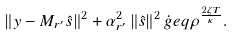Convert formula to latex. <formula><loc_0><loc_0><loc_500><loc_500>\left \| y - M _ { r ^ { \prime } } \hat { s } \right \| ^ { 2 } + \alpha _ { r ^ { \prime } } ^ { 2 } \left \| \hat { s } \right \| ^ { 2 } \dot { g } e q \rho ^ { \frac { 2 \zeta T } { \kappa } } .</formula> 